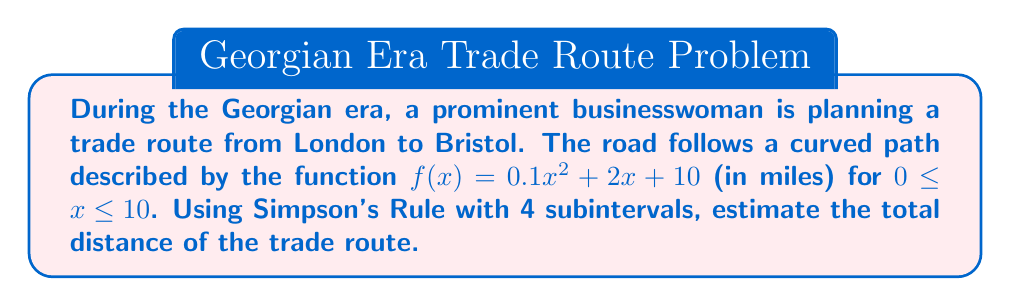Can you solve this math problem? To solve this problem using Simpson's Rule with 4 subintervals, we follow these steps:

1) Simpson's Rule formula:
   $$\int_a^b f(x)dx \approx \frac{h}{3}[f(x_0) + 4f(x_1) + 2f(x_2) + 4f(x_3) + f(x_4)]$$
   where $h = \frac{b-a}{n}$, and $n$ is the number of subintervals.

2) Given information:
   $a = 0$, $b = 10$, $n = 4$
   $f(x) = 0.1x^2 + 2x + 10$

3) Calculate $h$:
   $h = \frac{10-0}{4} = 2.5$

4) Calculate $x$ values:
   $x_0 = 0$
   $x_1 = 2.5$
   $x_2 = 5$
   $x_3 = 7.5$
   $x_4 = 10$

5) Calculate $f(x)$ values:
   $f(x_0) = f(0) = 10$
   $f(x_1) = f(2.5) = 0.1(2.5)^2 + 2(2.5) + 10 = 16.625$
   $f(x_2) = f(5) = 0.1(5)^2 + 2(5) + 10 = 22.5$
   $f(x_3) = f(7.5) = 0.1(7.5)^2 + 2(7.5) + 10 = 31.625$
   $f(x_4) = f(10) = 0.1(10)^2 + 2(10) + 10 = 40$

6) Apply Simpson's Rule:
   $$\text{Distance} \approx \frac{2.5}{3}[10 + 4(16.625) + 2(22.5) + 4(31.625) + 40]$$
   $$= \frac{2.5}{3}[10 + 66.5 + 45 + 126.5 + 40]$$
   $$= \frac{2.5}{3}[288]$$
   $$= 240 \text{ miles}$$

Therefore, the estimated total distance of the trade route is 240 miles.
Answer: 240 miles 